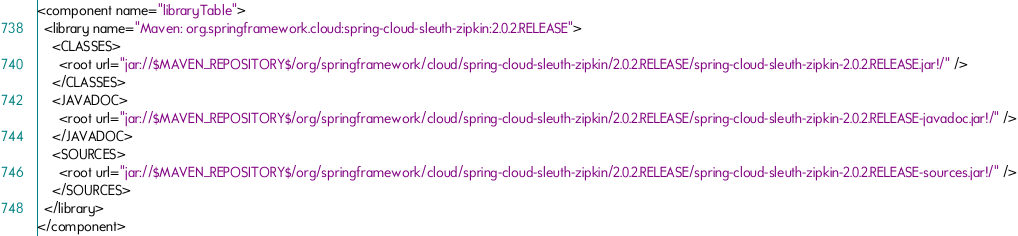<code> <loc_0><loc_0><loc_500><loc_500><_XML_><component name="libraryTable">
  <library name="Maven: org.springframework.cloud:spring-cloud-sleuth-zipkin:2.0.2.RELEASE">
    <CLASSES>
      <root url="jar://$MAVEN_REPOSITORY$/org/springframework/cloud/spring-cloud-sleuth-zipkin/2.0.2.RELEASE/spring-cloud-sleuth-zipkin-2.0.2.RELEASE.jar!/" />
    </CLASSES>
    <JAVADOC>
      <root url="jar://$MAVEN_REPOSITORY$/org/springframework/cloud/spring-cloud-sleuth-zipkin/2.0.2.RELEASE/spring-cloud-sleuth-zipkin-2.0.2.RELEASE-javadoc.jar!/" />
    </JAVADOC>
    <SOURCES>
      <root url="jar://$MAVEN_REPOSITORY$/org/springframework/cloud/spring-cloud-sleuth-zipkin/2.0.2.RELEASE/spring-cloud-sleuth-zipkin-2.0.2.RELEASE-sources.jar!/" />
    </SOURCES>
  </library>
</component></code> 